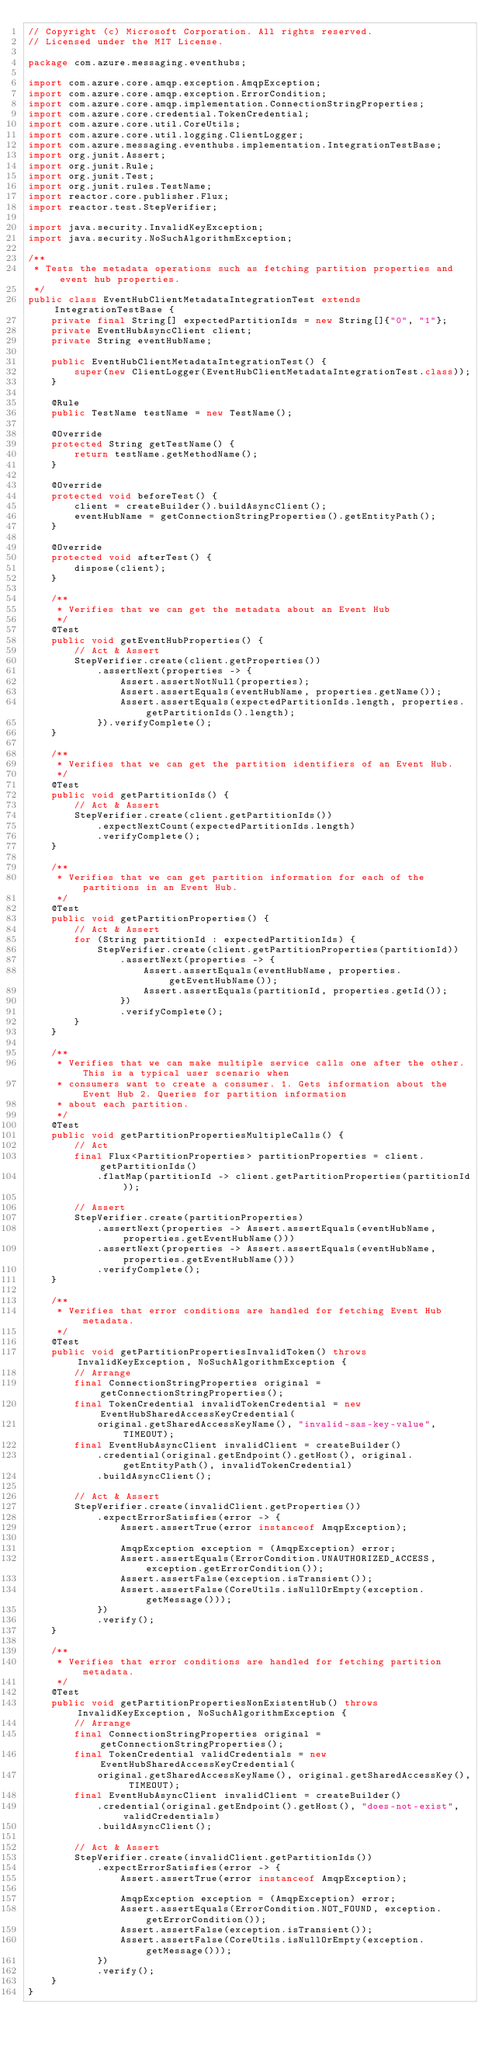Convert code to text. <code><loc_0><loc_0><loc_500><loc_500><_Java_>// Copyright (c) Microsoft Corporation. All rights reserved.
// Licensed under the MIT License.

package com.azure.messaging.eventhubs;

import com.azure.core.amqp.exception.AmqpException;
import com.azure.core.amqp.exception.ErrorCondition;
import com.azure.core.amqp.implementation.ConnectionStringProperties;
import com.azure.core.credential.TokenCredential;
import com.azure.core.util.CoreUtils;
import com.azure.core.util.logging.ClientLogger;
import com.azure.messaging.eventhubs.implementation.IntegrationTestBase;
import org.junit.Assert;
import org.junit.Rule;
import org.junit.Test;
import org.junit.rules.TestName;
import reactor.core.publisher.Flux;
import reactor.test.StepVerifier;

import java.security.InvalidKeyException;
import java.security.NoSuchAlgorithmException;

/**
 * Tests the metadata operations such as fetching partition properties and event hub properties.
 */
public class EventHubClientMetadataIntegrationTest extends IntegrationTestBase {
    private final String[] expectedPartitionIds = new String[]{"0", "1"};
    private EventHubAsyncClient client;
    private String eventHubName;

    public EventHubClientMetadataIntegrationTest() {
        super(new ClientLogger(EventHubClientMetadataIntegrationTest.class));
    }

    @Rule
    public TestName testName = new TestName();

    @Override
    protected String getTestName() {
        return testName.getMethodName();
    }

    @Override
    protected void beforeTest() {
        client = createBuilder().buildAsyncClient();
        eventHubName = getConnectionStringProperties().getEntityPath();
    }

    @Override
    protected void afterTest() {
        dispose(client);
    }

    /**
     * Verifies that we can get the metadata about an Event Hub
     */
    @Test
    public void getEventHubProperties() {
        // Act & Assert
        StepVerifier.create(client.getProperties())
            .assertNext(properties -> {
                Assert.assertNotNull(properties);
                Assert.assertEquals(eventHubName, properties.getName());
                Assert.assertEquals(expectedPartitionIds.length, properties.getPartitionIds().length);
            }).verifyComplete();
    }

    /**
     * Verifies that we can get the partition identifiers of an Event Hub.
     */
    @Test
    public void getPartitionIds() {
        // Act & Assert
        StepVerifier.create(client.getPartitionIds())
            .expectNextCount(expectedPartitionIds.length)
            .verifyComplete();
    }

    /**
     * Verifies that we can get partition information for each of the partitions in an Event Hub.
     */
    @Test
    public void getPartitionProperties() {
        // Act & Assert
        for (String partitionId : expectedPartitionIds) {
            StepVerifier.create(client.getPartitionProperties(partitionId))
                .assertNext(properties -> {
                    Assert.assertEquals(eventHubName, properties.getEventHubName());
                    Assert.assertEquals(partitionId, properties.getId());
                })
                .verifyComplete();
        }
    }

    /**
     * Verifies that we can make multiple service calls one after the other. This is a typical user scenario when
     * consumers want to create a consumer. 1. Gets information about the Event Hub 2. Queries for partition information
     * about each partition.
     */
    @Test
    public void getPartitionPropertiesMultipleCalls() {
        // Act
        final Flux<PartitionProperties> partitionProperties = client.getPartitionIds()
            .flatMap(partitionId -> client.getPartitionProperties(partitionId));

        // Assert
        StepVerifier.create(partitionProperties)
            .assertNext(properties -> Assert.assertEquals(eventHubName, properties.getEventHubName()))
            .assertNext(properties -> Assert.assertEquals(eventHubName, properties.getEventHubName()))
            .verifyComplete();
    }

    /**
     * Verifies that error conditions are handled for fetching Event Hub metadata.
     */
    @Test
    public void getPartitionPropertiesInvalidToken() throws InvalidKeyException, NoSuchAlgorithmException {
        // Arrange
        final ConnectionStringProperties original = getConnectionStringProperties();
        final TokenCredential invalidTokenCredential = new EventHubSharedAccessKeyCredential(
            original.getSharedAccessKeyName(), "invalid-sas-key-value", TIMEOUT);
        final EventHubAsyncClient invalidClient = createBuilder()
            .credential(original.getEndpoint().getHost(), original.getEntityPath(), invalidTokenCredential)
            .buildAsyncClient();

        // Act & Assert
        StepVerifier.create(invalidClient.getProperties())
            .expectErrorSatisfies(error -> {
                Assert.assertTrue(error instanceof AmqpException);

                AmqpException exception = (AmqpException) error;
                Assert.assertEquals(ErrorCondition.UNAUTHORIZED_ACCESS, exception.getErrorCondition());
                Assert.assertFalse(exception.isTransient());
                Assert.assertFalse(CoreUtils.isNullOrEmpty(exception.getMessage()));
            })
            .verify();
    }

    /**
     * Verifies that error conditions are handled for fetching partition metadata.
     */
    @Test
    public void getPartitionPropertiesNonExistentHub() throws InvalidKeyException, NoSuchAlgorithmException {
        // Arrange
        final ConnectionStringProperties original = getConnectionStringProperties();
        final TokenCredential validCredentials = new EventHubSharedAccessKeyCredential(
            original.getSharedAccessKeyName(), original.getSharedAccessKey(), TIMEOUT);
        final EventHubAsyncClient invalidClient = createBuilder()
            .credential(original.getEndpoint().getHost(), "does-not-exist", validCredentials)
            .buildAsyncClient();

        // Act & Assert
        StepVerifier.create(invalidClient.getPartitionIds())
            .expectErrorSatisfies(error -> {
                Assert.assertTrue(error instanceof AmqpException);

                AmqpException exception = (AmqpException) error;
                Assert.assertEquals(ErrorCondition.NOT_FOUND, exception.getErrorCondition());
                Assert.assertFalse(exception.isTransient());
                Assert.assertFalse(CoreUtils.isNullOrEmpty(exception.getMessage()));
            })
            .verify();
    }
}
</code> 